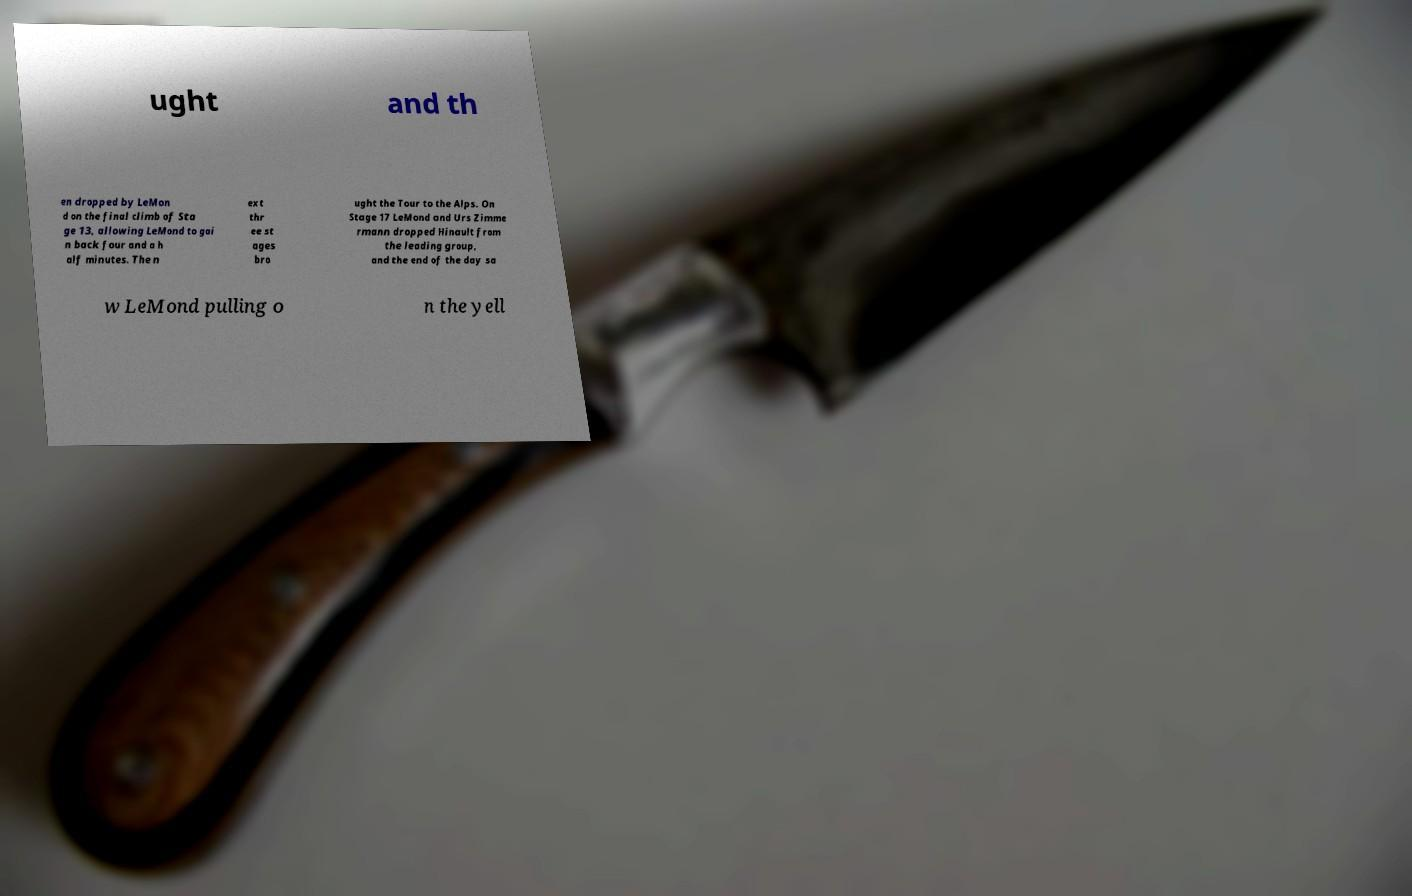Can you read and provide the text displayed in the image?This photo seems to have some interesting text. Can you extract and type it out for me? ught and th en dropped by LeMon d on the final climb of Sta ge 13, allowing LeMond to gai n back four and a h alf minutes. The n ext thr ee st ages bro ught the Tour to the Alps. On Stage 17 LeMond and Urs Zimme rmann dropped Hinault from the leading group, and the end of the day sa w LeMond pulling o n the yell 